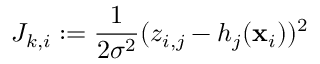Convert formula to latex. <formula><loc_0><loc_0><loc_500><loc_500>J _ { k , i } \colon = \frac { 1 } { 2 \sigma ^ { 2 } } ( z _ { i , j } - h _ { j } ( x _ { i } ) ) ^ { 2 }</formula> 